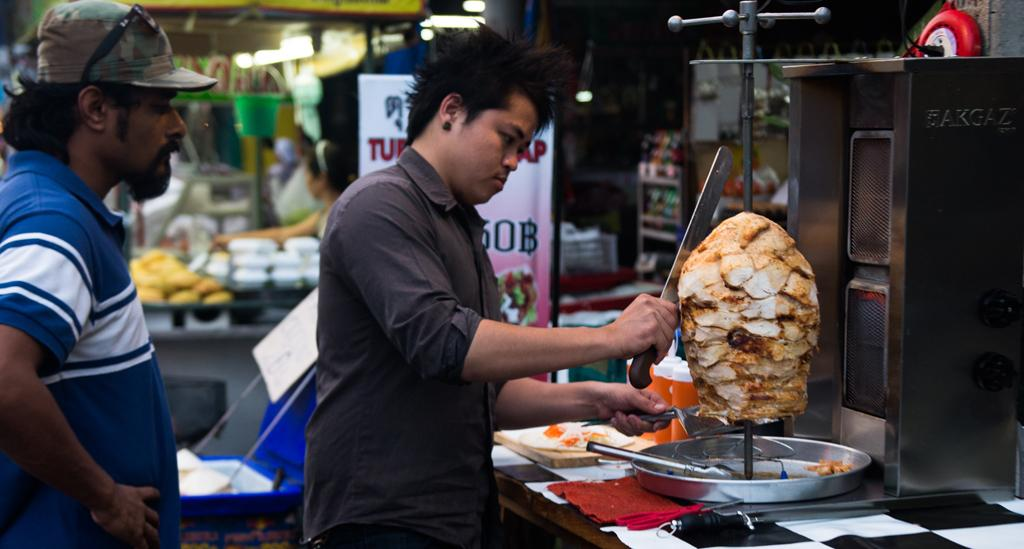How many individuals are present in the image? There are two people in the image. What type of soup is being prepared by the people in the image? There is no soup or any indication of food preparation in the image; it only shows two people. 